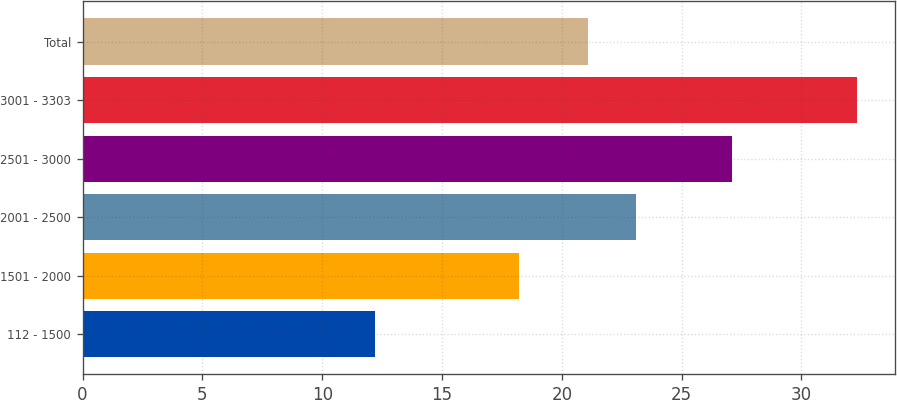<chart> <loc_0><loc_0><loc_500><loc_500><bar_chart><fcel>112 - 1500<fcel>1501 - 2000<fcel>2001 - 2500<fcel>2501 - 3000<fcel>3001 - 3303<fcel>Total<nl><fcel>12.22<fcel>18.22<fcel>23.11<fcel>27.09<fcel>32.31<fcel>21.1<nl></chart> 